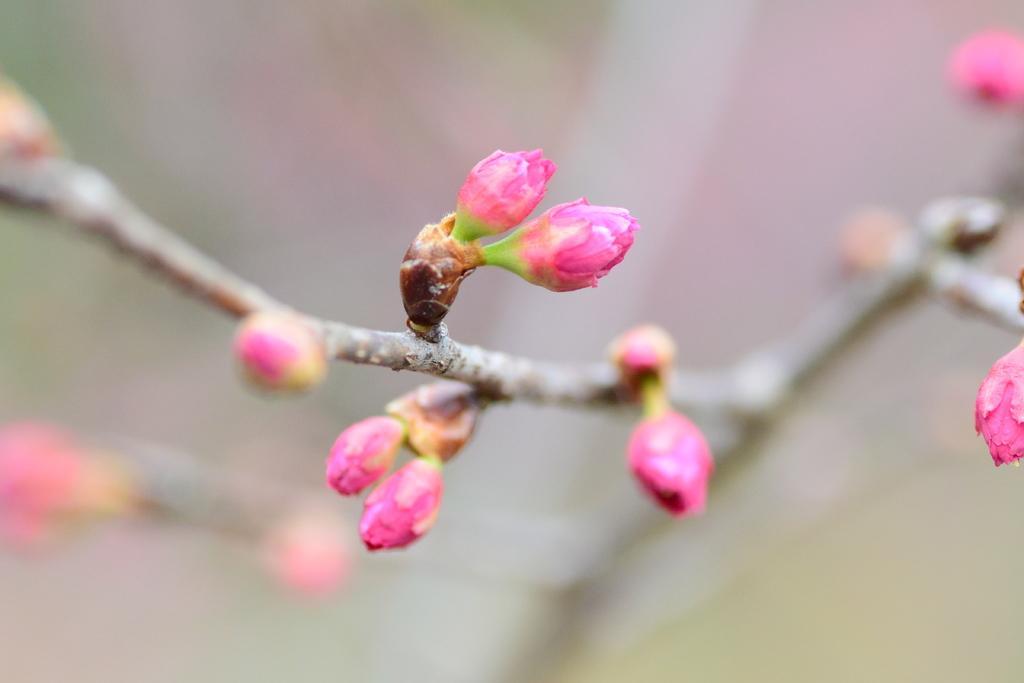Could you give a brief overview of what you see in this image? This is a plant. 